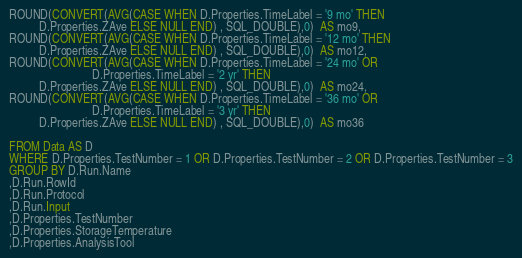<code> <loc_0><loc_0><loc_500><loc_500><_SQL_>ROUND(CONVERT(AVG(CASE WHEN D.Properties.TimeLabel = '9 mo' THEN
          D.Properties.ZAve ELSE NULL END) , SQL_DOUBLE),0)  AS mo9,
ROUND(CONVERT(AVG(CASE WHEN D.Properties.TimeLabel = '12 mo' THEN
          D.Properties.ZAve ELSE NULL END) , SQL_DOUBLE),0)  AS mo12,
ROUND(CONVERT(AVG(CASE WHEN D.Properties.TimeLabel = '24 mo' OR
                            D.Properties.TimeLabel = '2 yr' THEN
          D.Properties.ZAve ELSE NULL END) , SQL_DOUBLE),0)  AS mo24,
ROUND(CONVERT(AVG(CASE WHEN D.Properties.TimeLabel = '36 mo' OR
                            D.Properties.TimeLabel = '3 yr' THEN
          D.Properties.ZAve ELSE NULL END) , SQL_DOUBLE),0)  AS mo36

FROM Data AS D
WHERE D.Properties.TestNumber = 1 OR D.Properties.TestNumber = 2 OR D.Properties.TestNumber = 3
GROUP BY D.Run.Name
,D.Run.RowId
,D.Run.Protocol
,D.Run.Input
,D.Properties.TestNumber
,D.Properties.StorageTemperature
,D.Properties.AnalysisTool</code> 